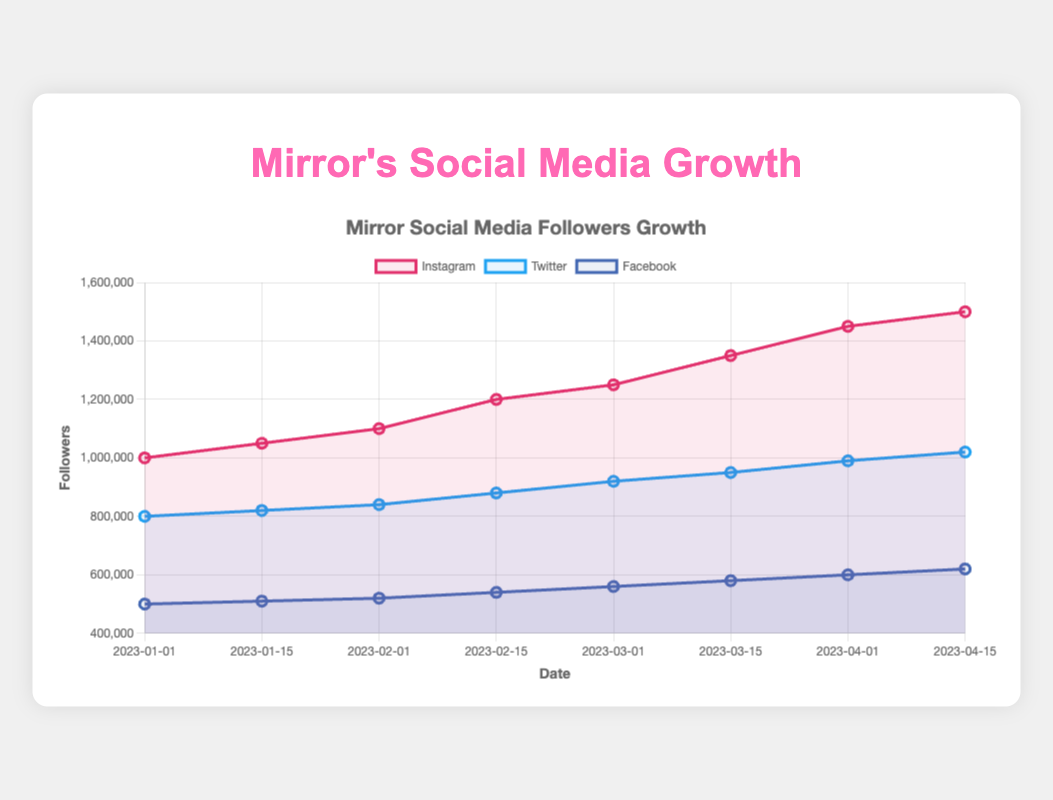What's the platform with the highest number of followers on 2023-04-15? On April 15th, 2023, Instagram has 1,500,000 followers, Twitter has 1,020,000 followers, and Facebook has 620,000 followers. Comparing these, Instagram has the highest number of followers.
Answer: Instagram What was the increase in followers on Instagram from March 1st to April 1st, 2023? On March 1st, 2023, Instagram had 1,250,000 followers, and on April 1st, 2023, it had 1,450,000 followers. The increase is 1,450,000 - 1,250,000 = 200,000 followers.
Answer: 200,000 Which platform showed the least growth from January 1 to April 15, 2023? Instagram grew from 1,000,000 to 1,500,000 followers, Twitter from 800,000 to 1,020,000 followers, and Facebook from 500,000 to 620,000 followers. The growth for Instagram is 500,000, for Twitter is 220,000, and for Facebook is 120,000. Facebook showed the least growth.
Answer: Facebook On which date did Twitter reach 950,000 followers? According to the data, Twitter reached 950,000 followers on March 15, 2023.
Answer: March 15, 2023 What is the average number of followers on Facebook over the given dates? The followers on Facebook over the dates are: 500,000, 510,000, 520,000, 540,000, 560,000, 580,000, 600,000, 620,000. The average number of followers is (500,000 + 510,000 + 520,000 + 540,000 + 560,000 + 580,000 + 600,000 + 620,000) / 8 = 553,750.
Answer: 553,750 Which platform had the fastest growth rate between January 1 and April 15, 2023? To determine the fastest growth rate, we calculate the growth percentage for each platform. Instagram grew from 1,000,000 to 1,500,000 (growth rate: 50%), Twitter grew from 800,000 to 1,020,000 (growth rate: 27.5%), and Facebook grew from 500,000 to 620,000 (growth rate: 24%). Instagram had the fastest growth rate.
Answer: Instagram How many total followers did all platforms have on February 1, 2023? On February 1, 2023, Instagram had 1,100,000 followers, Twitter had 840,000 followers, and Facebook had 520,000 followers. The total number of followers is 1,100,000 + 840,000 + 520,000 = 2,460,000.
Answer: 2,460,000 What is the difference in followers between Instagram and Facebook on March 15, 2023? On March 15, 2023, Instagram had 1,350,000 followers, and Facebook had 580,000 followers. The difference is 1,350,000 - 580,000 = 770,000.
Answer: 770,000 What trend can be observed in the follower growth on Twitter? Examining the Twitter data, it shows a consistent, steady increase in followers over the period, with a noticeable rise in followers in every subsequent recorded date.
Answer: Steady increase 